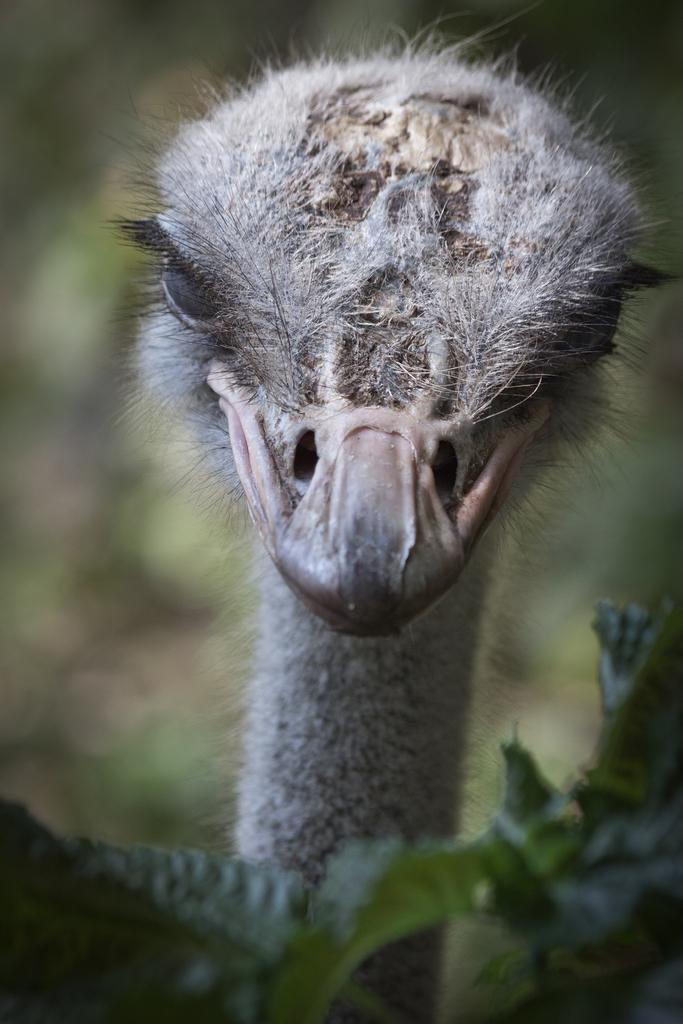Can you describe this image briefly? In this picture one bird which look like ostrich is staring. 